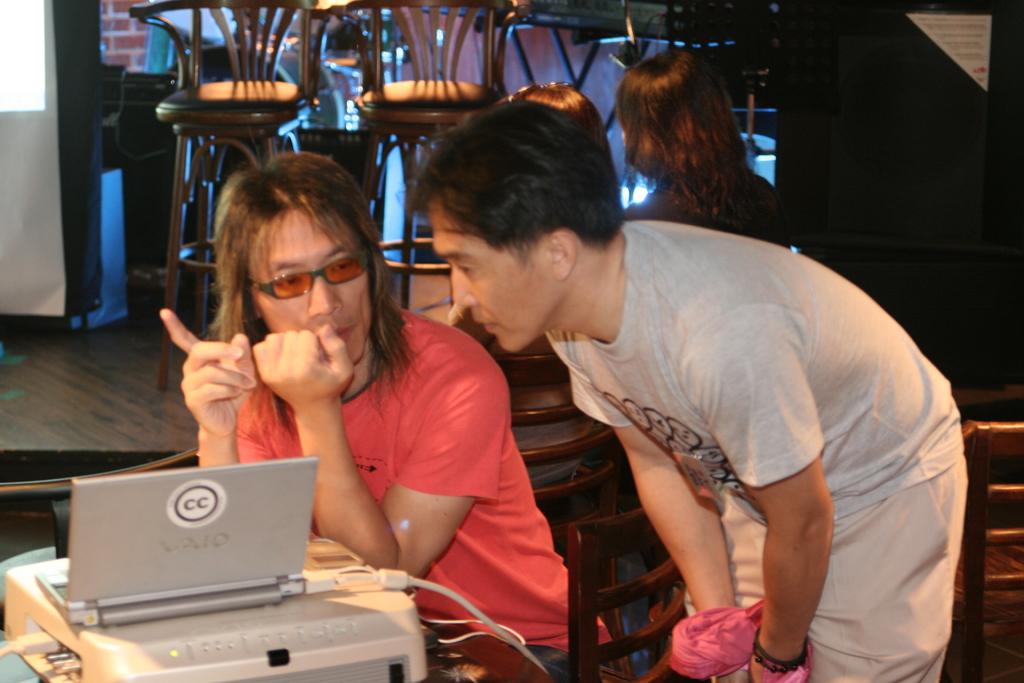Is that a vaio laptop?
Provide a succinct answer. Yes. What letters are printed on the sticker on the rear of the laptop?
Give a very brief answer. Cc. 